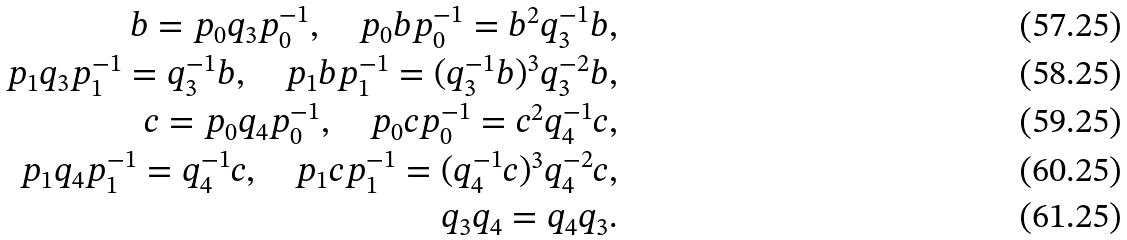<formula> <loc_0><loc_0><loc_500><loc_500>b = p _ { 0 } q _ { 3 } p _ { 0 } ^ { - 1 } , \quad p _ { 0 } b p _ { 0 } ^ { - 1 } = b ^ { 2 } q _ { 3 } ^ { - 1 } b , \\ p _ { 1 } q _ { 3 } p _ { 1 } ^ { - 1 } = q _ { 3 } ^ { - 1 } b , \quad p _ { 1 } b p _ { 1 } ^ { - 1 } = ( q _ { 3 } ^ { - 1 } b ) ^ { 3 } q _ { 3 } ^ { - 2 } b , \\ c = p _ { 0 } q _ { 4 } p _ { 0 } ^ { - 1 } , \quad p _ { 0 } c p _ { 0 } ^ { - 1 } = c ^ { 2 } q _ { 4 } ^ { - 1 } c , \\ p _ { 1 } q _ { 4 } p _ { 1 } ^ { - 1 } = q _ { 4 } ^ { - 1 } c , \quad p _ { 1 } c p _ { 1 } ^ { - 1 } = ( q _ { 4 } ^ { - 1 } c ) ^ { 3 } q _ { 4 } ^ { - 2 } c , \\ q _ { 3 } q _ { 4 } = q _ { 4 } q _ { 3 } .</formula> 